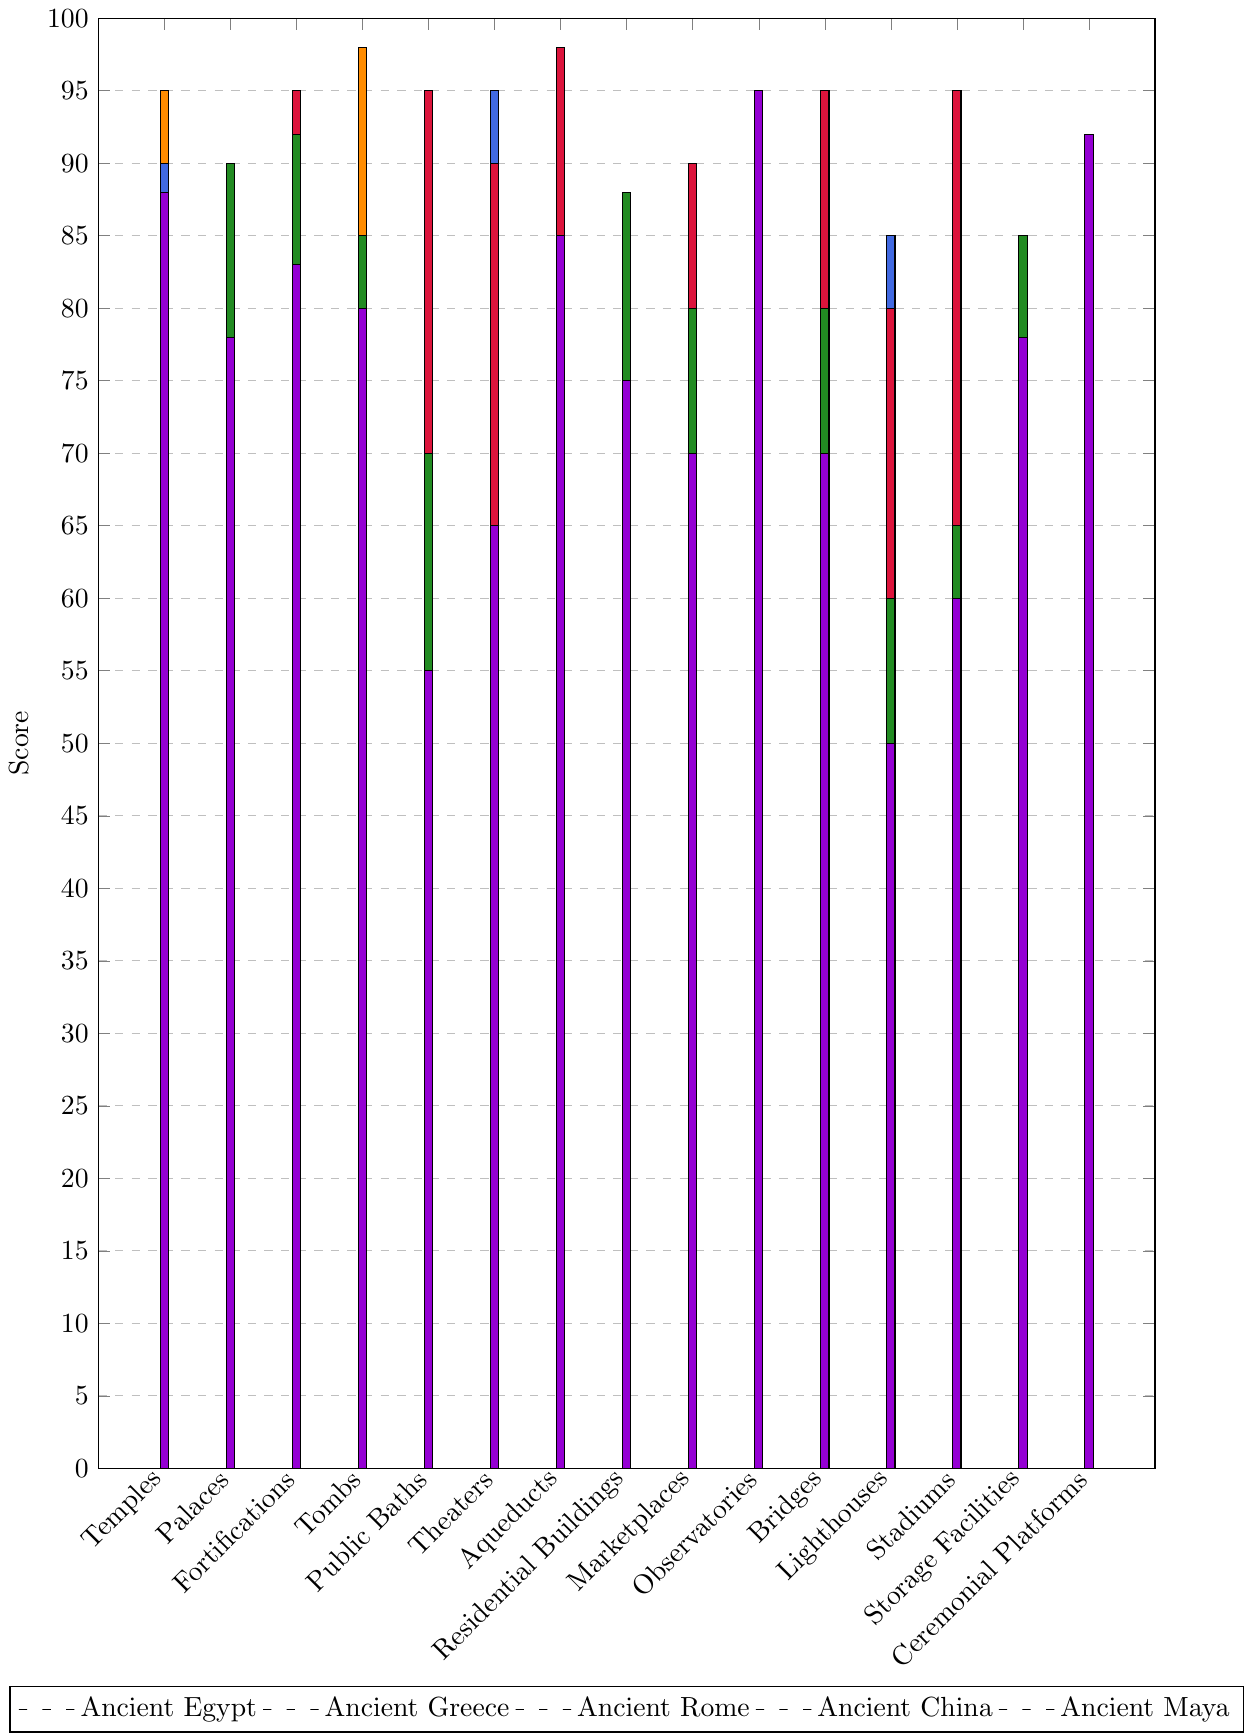Which ancient civilization has the highest score for Temples? Observing the bar heights for the Temples category, the tallest bar indicates the highest score. Ancient Egypt's bar is the tallest.
Answer: Ancient Egypt Which ancient civilization scores the highest for Public Baths? Check the bars under Public Baths. The tallest one belongs to Ancient Rome.
Answer: Ancient Rome How does Ancient Greece compare to Ancient Rome in the Theaters category? Observing the bars for both civilizations in the Theaters category, Ancient Greece has a higher bar than Ancient Rome.
Answer: Ancient Greece What is the combined score of Ancient Maya for Aqueducts and Observatories? Sum the scores for Ancient Maya in Aqueducts (85) and Observatories (95): 85 + 95.
Answer: 180 Which civilization has the lowest score for Lighthouses? Observing the bars for the Lighthouses category, the shortest bar belongs to Ancient Maya.
Answer: Ancient Maya What is the difference between the scores of Ancient Egypt and Ancient Maya for Tombs? Subtract Ancient Maya's score (80) from Ancient Egypt's score (98): 98 - 80.
Answer: 18 Which building type does Ancient Rome excel the most compared to others? Identify the category where Ancient Rome has a taller bar than all other civilizations. Ancient Rome has the highest score for Aqueducts.
Answer: Aqueducts Which building type shows the highest variance in score among the civilizations? Identify the building type with the most visual variation in bar heights. The Temples category exhibits significant variance among civilizations.
Answer: Temples What building type has the same score across two different ancient civilizations, one of which is Ancient China? Look for two bars of the same height across different civilizations where one bar is for Ancient China. For Storage Facilities, both Ancient China and Ancient Maya have the same score of 78.
Answer: Storage Facilities Among the Palaces, which two ancient civilizations have scores closest to each other? Compare the heights of bars in the Palaces category and find the two bars closest in height. Ancient Egypt (75) and Ancient Greece (70) are the closest.
Answer: Ancient Egypt and Ancient Greece 